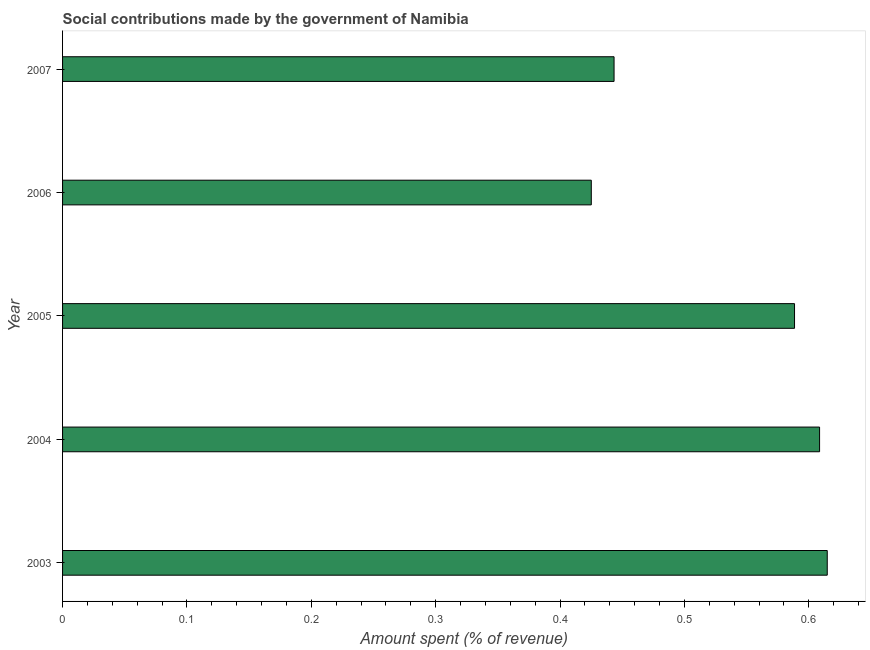Does the graph contain any zero values?
Ensure brevity in your answer.  No. Does the graph contain grids?
Keep it short and to the point. No. What is the title of the graph?
Provide a short and direct response. Social contributions made by the government of Namibia. What is the label or title of the X-axis?
Offer a terse response. Amount spent (% of revenue). What is the amount spent in making social contributions in 2004?
Provide a short and direct response. 0.61. Across all years, what is the maximum amount spent in making social contributions?
Keep it short and to the point. 0.61. Across all years, what is the minimum amount spent in making social contributions?
Provide a short and direct response. 0.43. In which year was the amount spent in making social contributions maximum?
Provide a succinct answer. 2003. What is the sum of the amount spent in making social contributions?
Your answer should be compact. 2.68. What is the average amount spent in making social contributions per year?
Ensure brevity in your answer.  0.54. What is the median amount spent in making social contributions?
Your answer should be very brief. 0.59. In how many years, is the amount spent in making social contributions greater than 0.4 %?
Provide a short and direct response. 5. What is the ratio of the amount spent in making social contributions in 2005 to that in 2007?
Make the answer very short. 1.33. Is the amount spent in making social contributions in 2006 less than that in 2007?
Provide a short and direct response. Yes. What is the difference between the highest and the second highest amount spent in making social contributions?
Provide a short and direct response. 0.01. What is the difference between the highest and the lowest amount spent in making social contributions?
Your answer should be very brief. 0.19. Are all the bars in the graph horizontal?
Make the answer very short. Yes. How many years are there in the graph?
Make the answer very short. 5. What is the difference between two consecutive major ticks on the X-axis?
Offer a very short reply. 0.1. Are the values on the major ticks of X-axis written in scientific E-notation?
Make the answer very short. No. What is the Amount spent (% of revenue) of 2003?
Offer a terse response. 0.61. What is the Amount spent (% of revenue) of 2004?
Offer a very short reply. 0.61. What is the Amount spent (% of revenue) in 2005?
Give a very brief answer. 0.59. What is the Amount spent (% of revenue) of 2006?
Your response must be concise. 0.43. What is the Amount spent (% of revenue) of 2007?
Keep it short and to the point. 0.44. What is the difference between the Amount spent (% of revenue) in 2003 and 2004?
Keep it short and to the point. 0.01. What is the difference between the Amount spent (% of revenue) in 2003 and 2005?
Ensure brevity in your answer.  0.03. What is the difference between the Amount spent (% of revenue) in 2003 and 2006?
Your response must be concise. 0.19. What is the difference between the Amount spent (% of revenue) in 2003 and 2007?
Your response must be concise. 0.17. What is the difference between the Amount spent (% of revenue) in 2004 and 2005?
Your response must be concise. 0.02. What is the difference between the Amount spent (% of revenue) in 2004 and 2006?
Your response must be concise. 0.18. What is the difference between the Amount spent (% of revenue) in 2004 and 2007?
Provide a short and direct response. 0.17. What is the difference between the Amount spent (% of revenue) in 2005 and 2006?
Keep it short and to the point. 0.16. What is the difference between the Amount spent (% of revenue) in 2005 and 2007?
Your answer should be very brief. 0.15. What is the difference between the Amount spent (% of revenue) in 2006 and 2007?
Your answer should be very brief. -0.02. What is the ratio of the Amount spent (% of revenue) in 2003 to that in 2004?
Ensure brevity in your answer.  1.01. What is the ratio of the Amount spent (% of revenue) in 2003 to that in 2005?
Give a very brief answer. 1.04. What is the ratio of the Amount spent (% of revenue) in 2003 to that in 2006?
Your answer should be very brief. 1.45. What is the ratio of the Amount spent (% of revenue) in 2003 to that in 2007?
Make the answer very short. 1.39. What is the ratio of the Amount spent (% of revenue) in 2004 to that in 2005?
Your response must be concise. 1.03. What is the ratio of the Amount spent (% of revenue) in 2004 to that in 2006?
Give a very brief answer. 1.43. What is the ratio of the Amount spent (% of revenue) in 2004 to that in 2007?
Offer a very short reply. 1.37. What is the ratio of the Amount spent (% of revenue) in 2005 to that in 2006?
Keep it short and to the point. 1.38. What is the ratio of the Amount spent (% of revenue) in 2005 to that in 2007?
Provide a short and direct response. 1.33. 